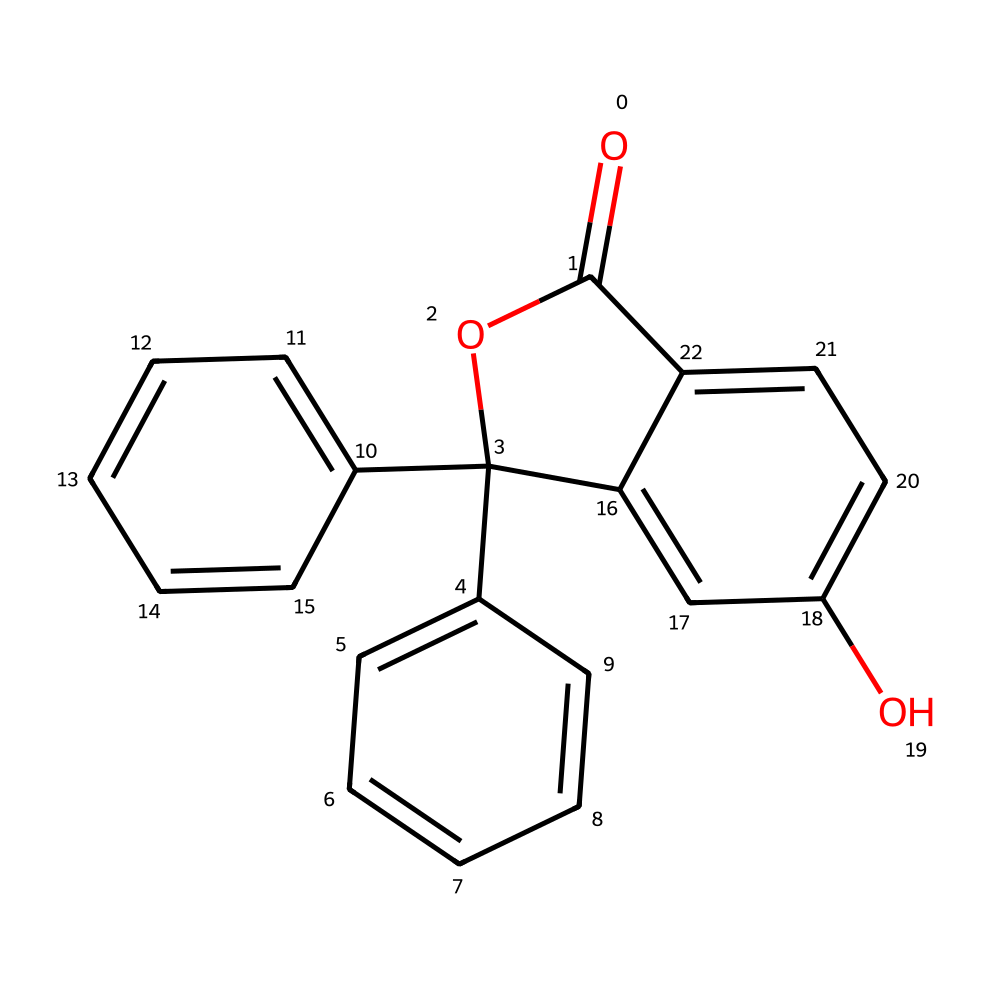How many rings are present in the molecular structure of phenolphthalein? The structure contains three distinct ring systems: two phenyl rings and one central ring that includes the ester functionality. By counting the recognizable cyclic structures, we arrive at three rings.
Answer: three What is the functional group present in phenolphthalein? The functional group that characterizes phenolphthalein is the ester group (–COO–). Identifying the characteristic carbonyl (C=O) and the oxygen connected to the aromatic system allows us to determine it is an ester.
Answer: ester What is the molecular formula of phenolphthalein based on its structure? Analyzing the structure reveals the presence of 20 carbons (C), 14 hydrogens (H), and 4 oxygens (O). Summing the contributions of each type of atom provides the molecular formula C20H14O4.
Answer: C20H14O4 Does phenolphthalein change color when exposed to acids, and if so, what colors are observed? Yes, phenolphthalein acts as a pH indicator that transitions from colorless in acidic solutions (pH < 7) to pink in basic solutions (pH > 8). This property can be inferred from its role as an acid-base indicator.
Answer: colorless to pink What type of compound is phenolphthalein classified as? Phenolphthalein is classified as a synthetic organic dye due to its man-made synthesis and its use in coloration and pH indication. Recognizing its application and chemical categorization confirms this classification.
Answer: synthetic dye How many oxygen atoms are there in the structure of phenolphthalein? Examining the molecular structure reveals precisely four oxygen atoms positioned in various functional arrangements, including the carbonyl and hydroxyl groups. Counting these leads to the answer.
Answer: four 